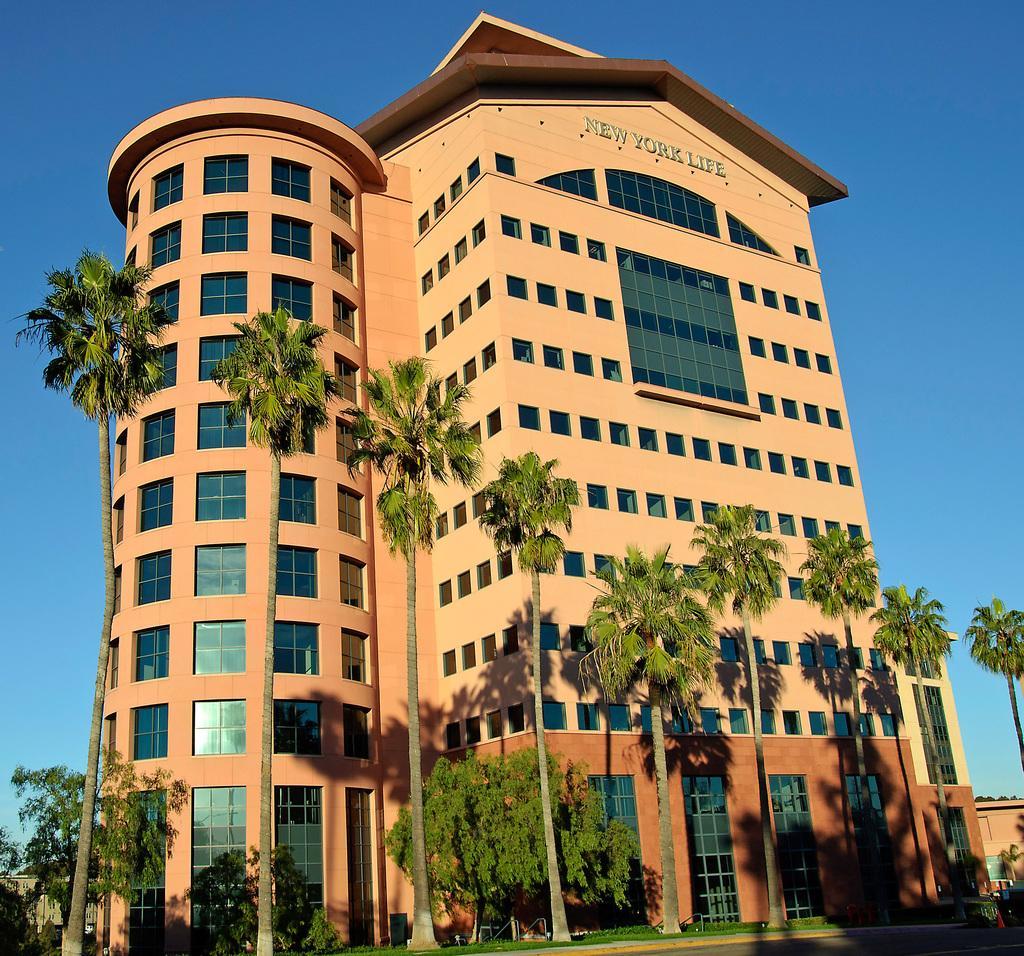Can you describe this image briefly? In this image we can see a building. There are many trees in the image. There is a grassy land in the image. We can see the sky in the image. We can see some text on the building. 